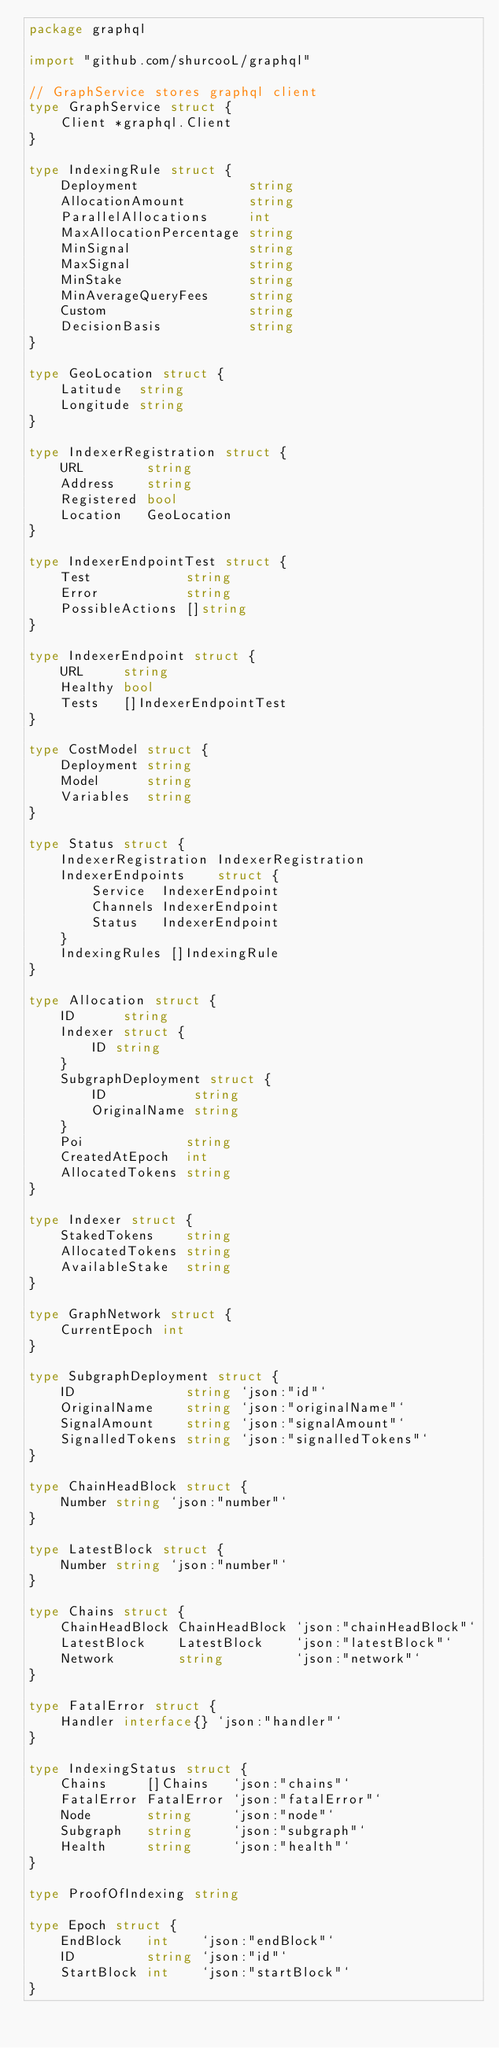Convert code to text. <code><loc_0><loc_0><loc_500><loc_500><_Go_>package graphql

import "github.com/shurcooL/graphql"

// GraphService stores graphql client
type GraphService struct {
	Client *graphql.Client
}

type IndexingRule struct {
	Deployment              string
	AllocationAmount        string
	ParallelAllocations     int
	MaxAllocationPercentage string
	MinSignal               string
	MaxSignal               string
	MinStake                string
	MinAverageQueryFees     string
	Custom                  string
	DecisionBasis           string
}

type GeoLocation struct {
	Latitude  string
	Longitude string
}

type IndexerRegistration struct {
	URL        string
	Address    string
	Registered bool
	Location   GeoLocation
}

type IndexerEndpointTest struct {
	Test            string
	Error           string
	PossibleActions []string
}

type IndexerEndpoint struct {
	URL     string
	Healthy bool
	Tests   []IndexerEndpointTest
}

type CostModel struct {
	Deployment string
	Model      string
	Variables  string
}

type Status struct {
	IndexerRegistration IndexerRegistration
	IndexerEndpoints    struct {
		Service  IndexerEndpoint
		Channels IndexerEndpoint
		Status   IndexerEndpoint
	}
	IndexingRules []IndexingRule
}

type Allocation struct {
	ID      string
	Indexer struct {
		ID string
	}
	SubgraphDeployment struct {
		ID           string
		OriginalName string
	}
	Poi             string
	CreatedAtEpoch  int
	AllocatedTokens string
}

type Indexer struct {
	StakedTokens    string
	AllocatedTokens string
	AvailableStake  string
}

type GraphNetwork struct {
	CurrentEpoch int
}

type SubgraphDeployment struct {
	ID              string `json:"id"`
	OriginalName    string `json:"originalName"`
	SignalAmount    string `json:"signalAmount"`
	SignalledTokens string `json:"signalledTokens"`
}

type ChainHeadBlock struct {
	Number string `json:"number"`
}

type LatestBlock struct {
	Number string `json:"number"`
}

type Chains struct {
	ChainHeadBlock ChainHeadBlock `json:"chainHeadBlock"`
	LatestBlock    LatestBlock    `json:"latestBlock"`
	Network        string         `json:"network"`
}

type FatalError struct {
	Handler interface{} `json:"handler"`
}

type IndexingStatus struct {
	Chains     []Chains   `json:"chains"`
	FatalError FatalError `json:"fatalError"`
	Node       string     `json:"node"`
	Subgraph   string     `json:"subgraph"`
	Health     string     `json:"health"`
}

type ProofOfIndexing string

type Epoch struct {
	EndBlock   int    `json:"endBlock"`
	ID         string `json:"id"`
	StartBlock int    `json:"startBlock"`
}
</code> 